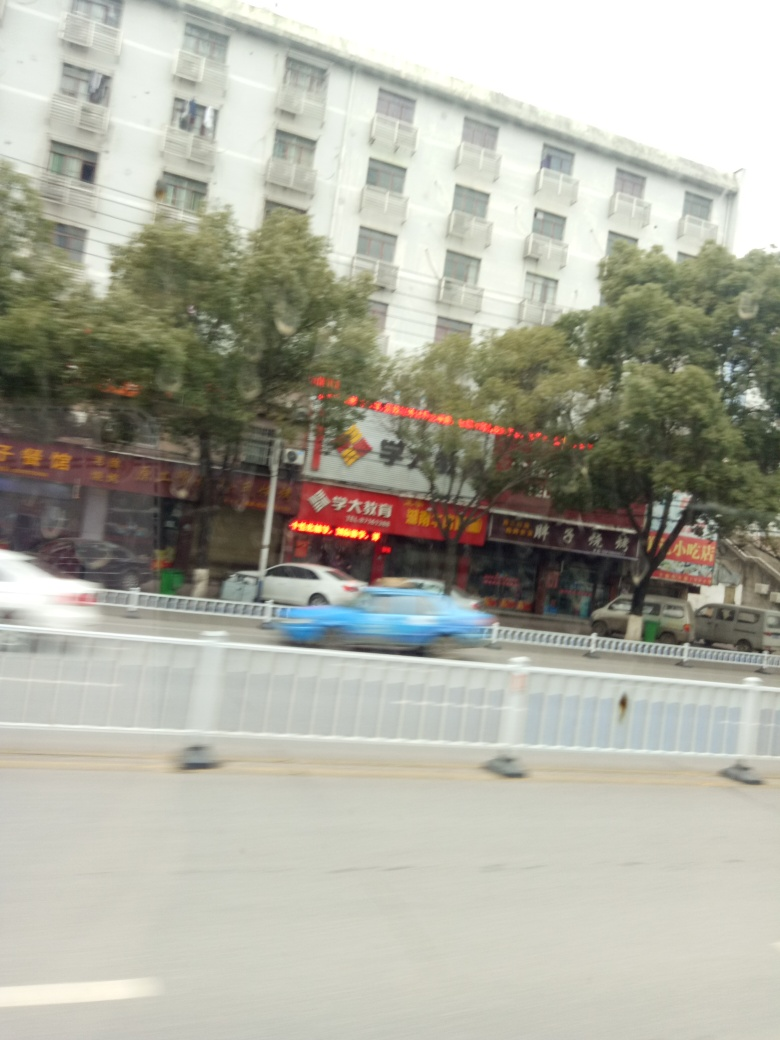What is the quality of the lighting in the image? The image exhibits natural daylight conditions with diffuse, overcast light, providing even illumination without harsh shadows. The sky is overcast and the overall ambiance is somewhat gloomy, which suggests weak lighting conditions and a lack of direct sunlight. 